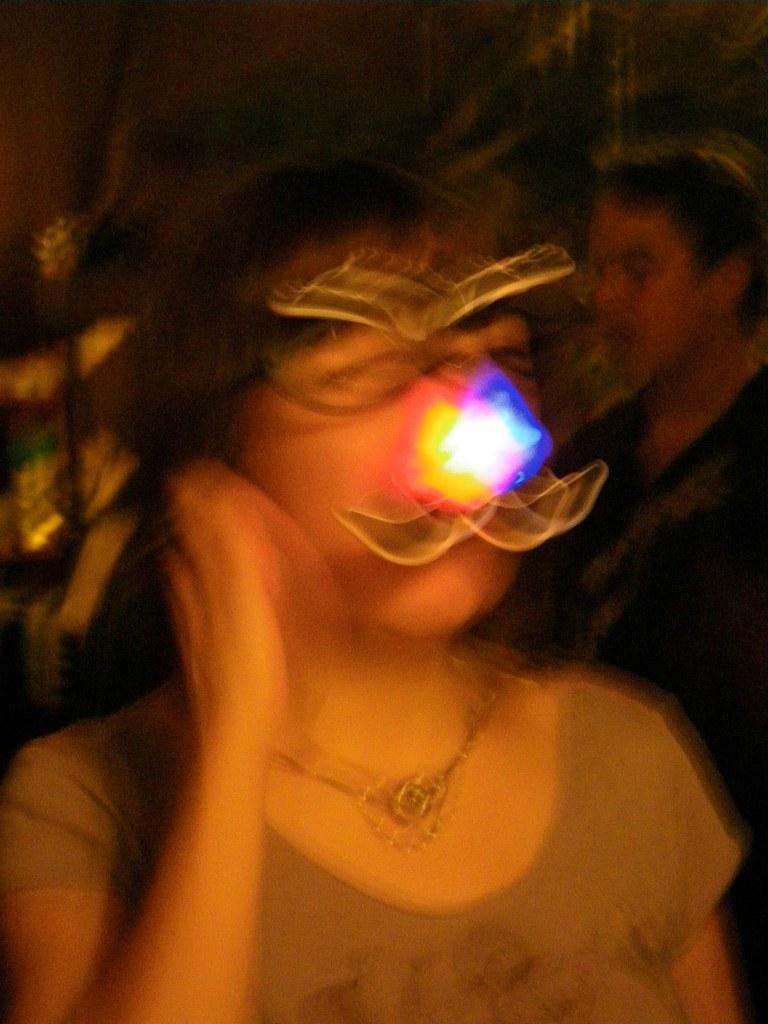Can you describe this image briefly? In this image, I can see two people standing. This image looks slightly blurred. 